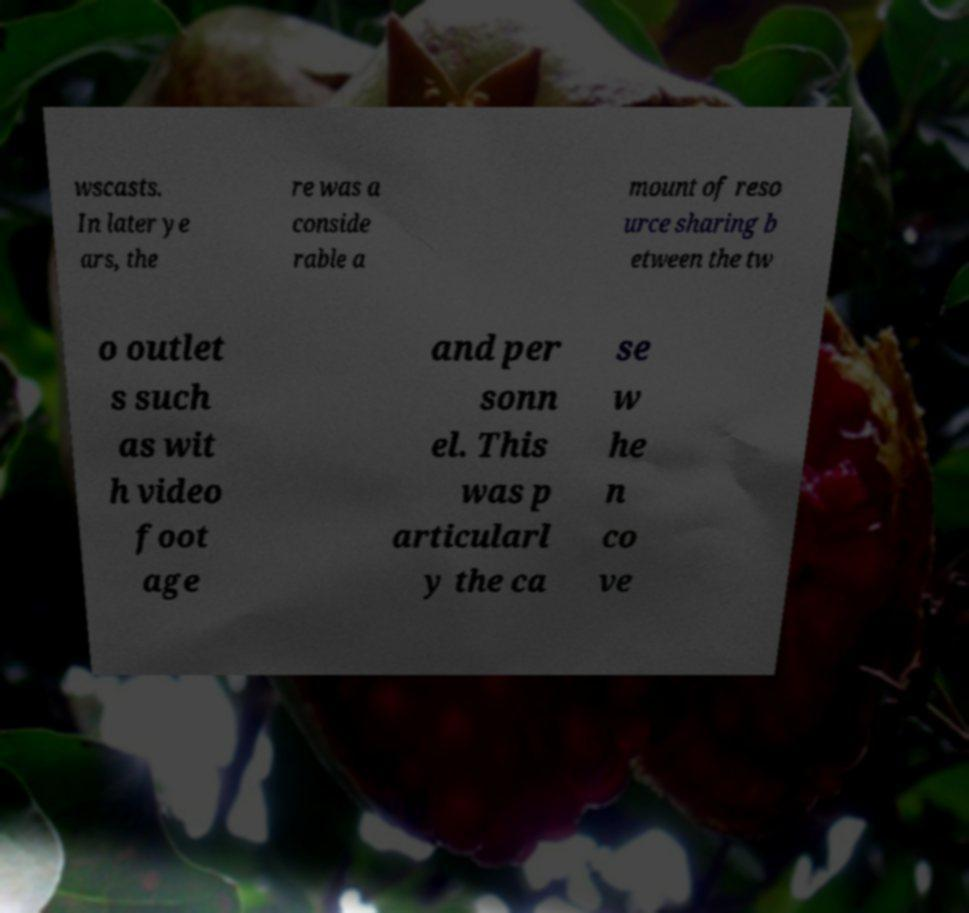What messages or text are displayed in this image? I need them in a readable, typed format. wscasts. In later ye ars, the re was a conside rable a mount of reso urce sharing b etween the tw o outlet s such as wit h video foot age and per sonn el. This was p articularl y the ca se w he n co ve 